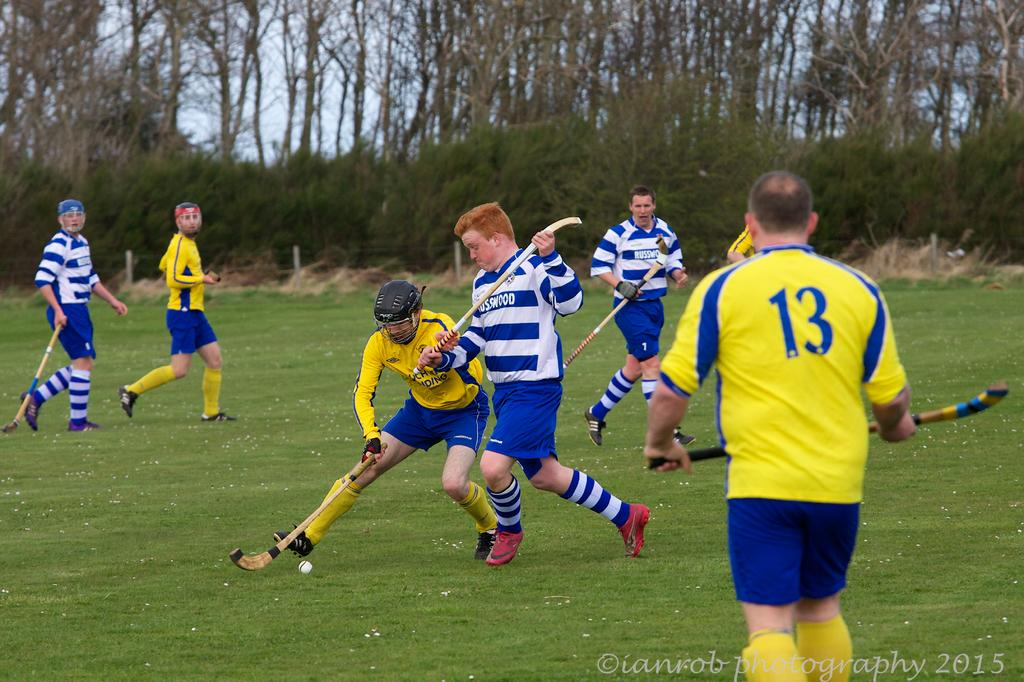<image>
Write a terse but informative summary of the picture. A group of men playing field hockey, with on player wearing the number 13 on the back of his jersey. 